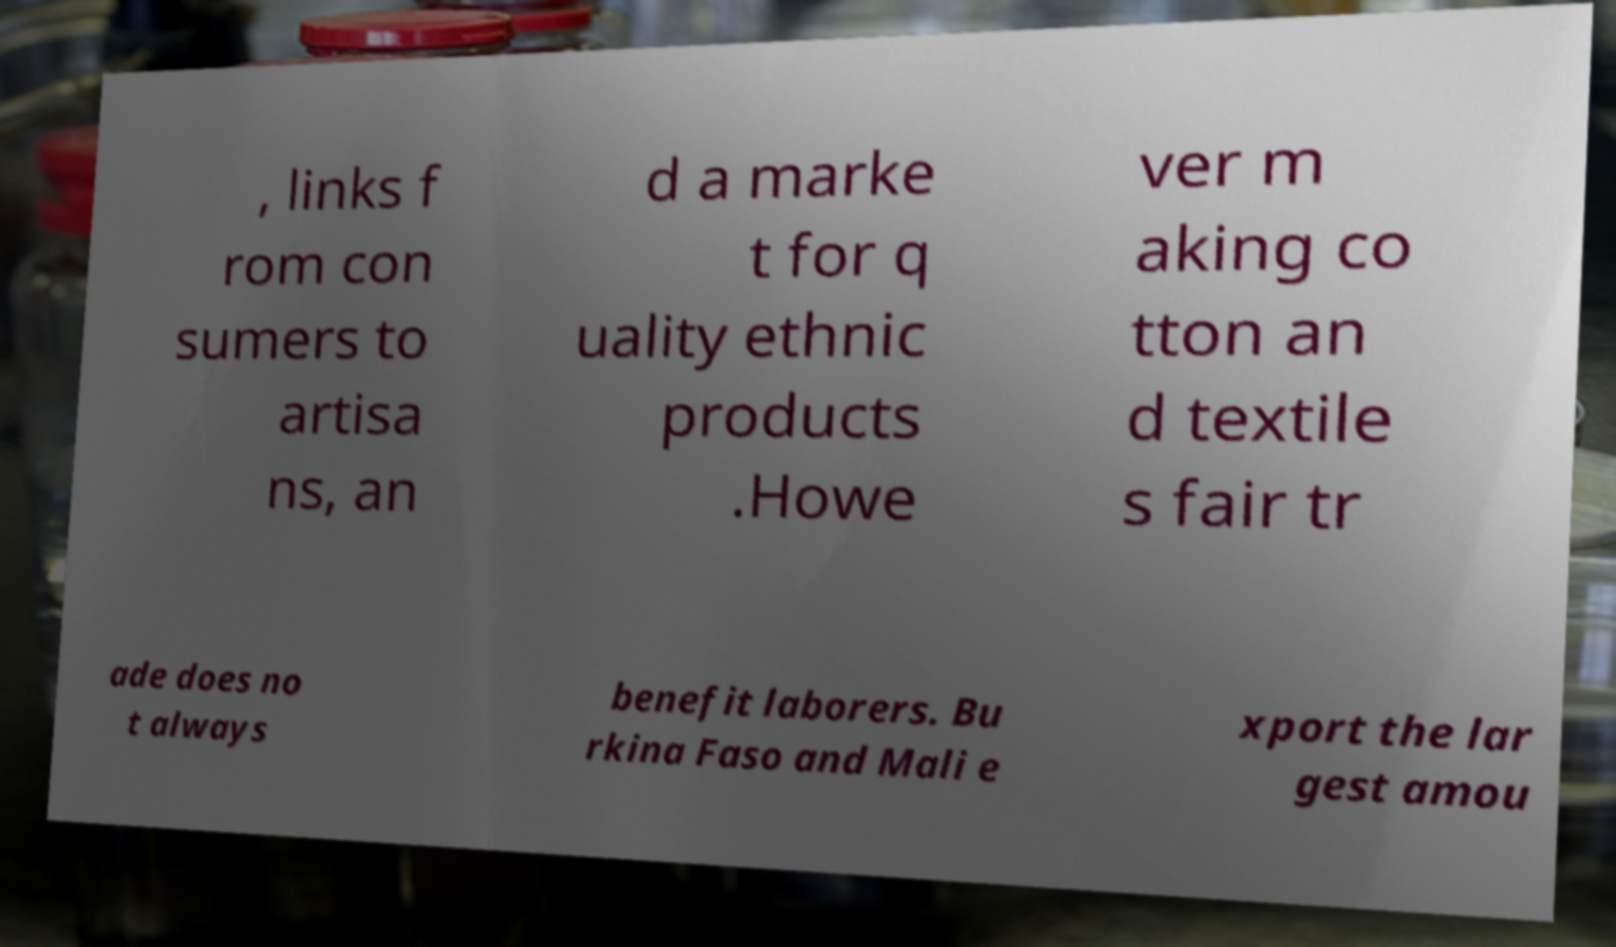I need the written content from this picture converted into text. Can you do that? , links f rom con sumers to artisa ns, an d a marke t for q uality ethnic products .Howe ver m aking co tton an d textile s fair tr ade does no t always benefit laborers. Bu rkina Faso and Mali e xport the lar gest amou 